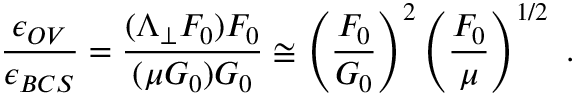Convert formula to latex. <formula><loc_0><loc_0><loc_500><loc_500>\frac { \epsilon _ { O V } } { \epsilon _ { B C S } } = \frac { ( \Lambda _ { \perp } F _ { 0 } ) F _ { 0 } } { ( \mu G _ { 0 } ) G _ { 0 } } \cong \left ( \frac { F _ { 0 } } { G _ { 0 } } \right ) ^ { 2 } \left ( \frac { F _ { 0 } } { \mu } \right ) ^ { 1 / 2 } \, .</formula> 